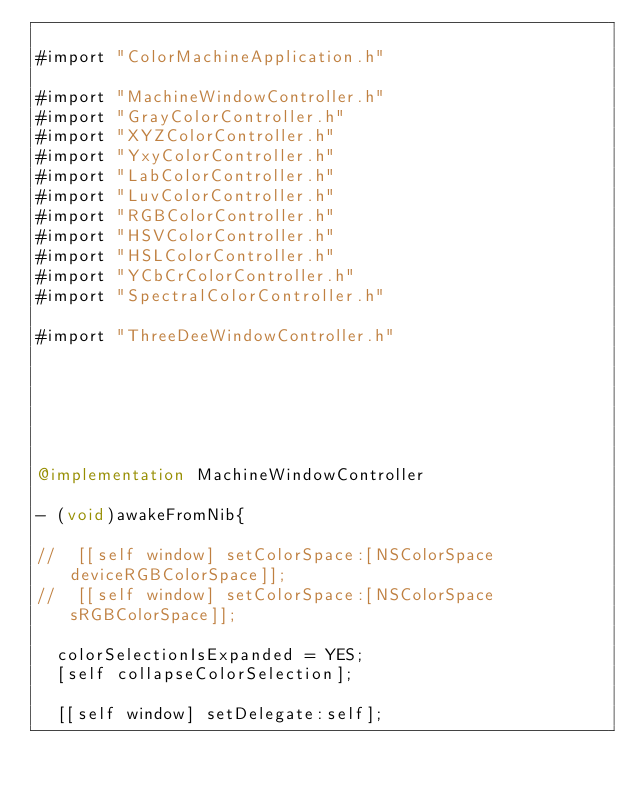<code> <loc_0><loc_0><loc_500><loc_500><_ObjectiveC_>
#import "ColorMachineApplication.h"

#import "MachineWindowController.h"
#import "GrayColorController.h"
#import "XYZColorController.h"
#import "YxyColorController.h"
#import "LabColorController.h"
#import "LuvColorController.h"
#import "RGBColorController.h"
#import "HSVColorController.h"
#import "HSLColorController.h"
#import "YCbCrColorController.h"
#import "SpectralColorController.h"

#import "ThreeDeeWindowController.h"






@implementation MachineWindowController

- (void)awakeFromNib{

//  [[self window] setColorSpace:[NSColorSpace deviceRGBColorSpace]];
//  [[self window] setColorSpace:[NSColorSpace sRGBColorSpace]];
  
  colorSelectionIsExpanded = YES;
  [self collapseColorSelection];

  [[self window] setDelegate:self];
  
  </code> 